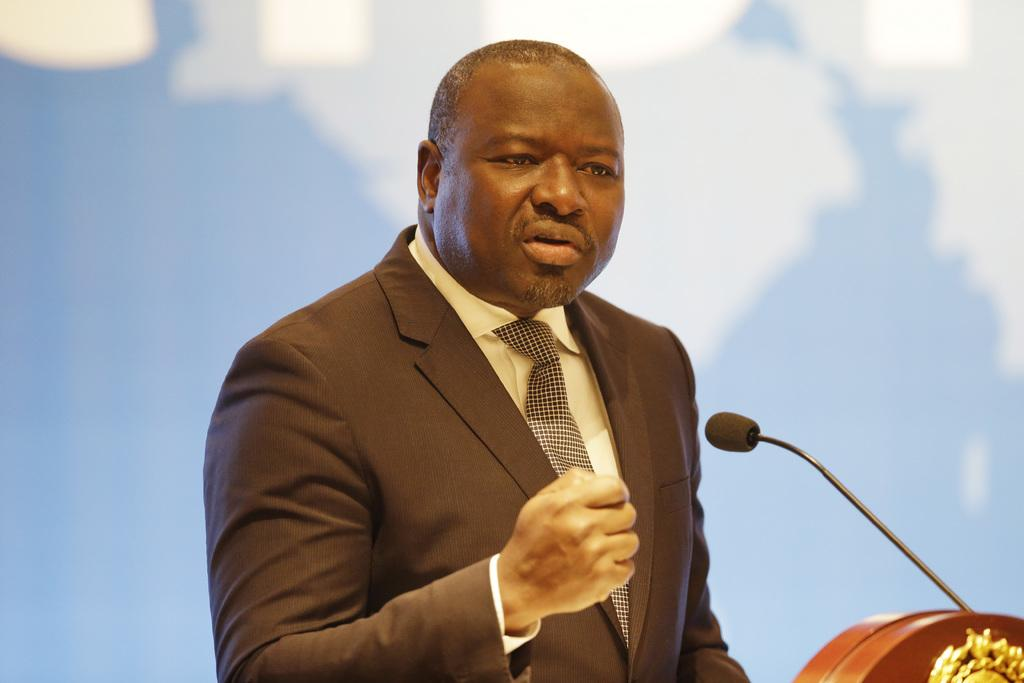Who is present in the image? There is a man in the image. What is the man doing in the image? The man is speaking in the image. Can you describe the background of the image? The background of the man is blurred in the image. What type of bubble can be seen floating near the man in the image? There is no bubble present in the image; it only features a man speaking with a blurred background. 